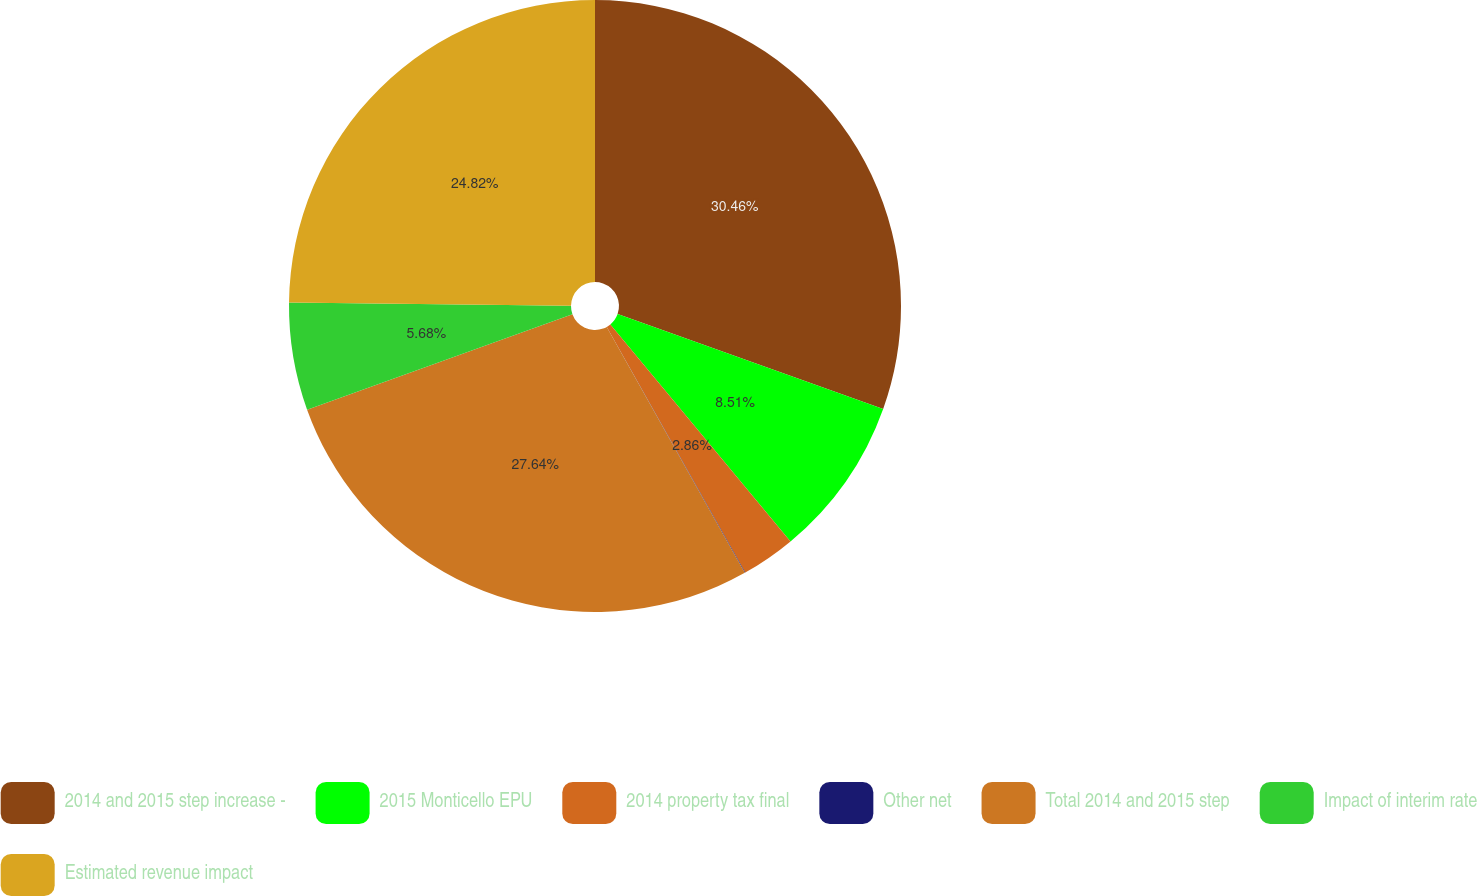Convert chart. <chart><loc_0><loc_0><loc_500><loc_500><pie_chart><fcel>2014 and 2015 step increase -<fcel>2015 Monticello EPU<fcel>2014 property tax final<fcel>Other net<fcel>Total 2014 and 2015 step<fcel>Impact of interim rate<fcel>Estimated revenue impact<nl><fcel>30.46%<fcel>8.51%<fcel>2.86%<fcel>0.03%<fcel>27.64%<fcel>5.68%<fcel>24.82%<nl></chart> 